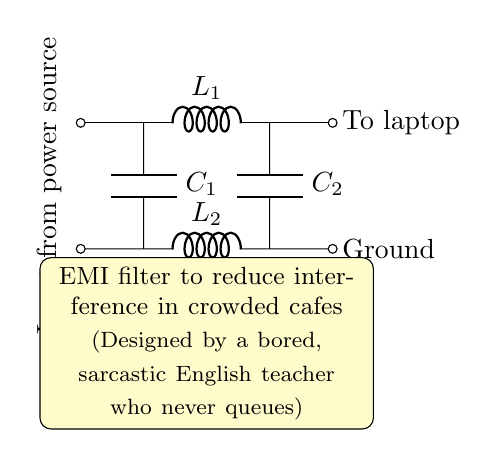What is the input to this circuit? The input is coming from the power source, indicated by the label at the top left of the circuit diagram.
Answer: power source What components are present in this EMI filter? The EMI filter consists of two inductors (L1 and L2) and two capacitors (C1 and C2). These components are labeled directly in the circuit diagram.
Answer: L1, L2, C1, C2 How many capacitors does this filter have? The diagram shows two capacitors labeled C1 and C2, which can be counted directly from the visual representation of the circuit.
Answer: 2 What is the purpose of this EMI filter? The label below the circuit diagram states that the purpose is to reduce interference in crowded cafes. This descriptive statement directly answers the question.
Answer: reduce interference Which component is connected to the laptop? The circuit diagram indicates that L1 connects to the output on the right side designated as "To laptop," naming the component directly involved with the laptop connection.
Answer: L1 What is the relationship between L1 and C1? L1 and C1 are in parallel arrangement, as seen from the diagram, meaning that they share the same voltage across them while the current may split between the two components.
Answer: parallel Why are there two inductors in this filter? Inductors L1 and L2 serve to filter different frequency ranges or to provide additional attenuation of electromagnetic interference, which can be inferred from circuit design principles typically used in EMI filtering.
Answer: attenuation 